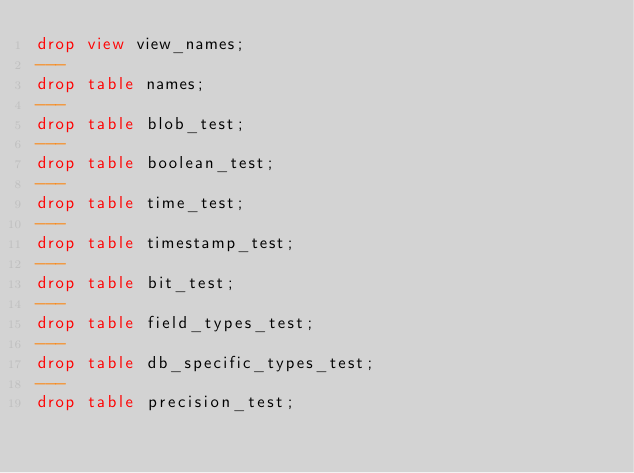<code> <loc_0><loc_0><loc_500><loc_500><_SQL_>drop view view_names;
---
drop table names;
---
drop table blob_test;
---
drop table boolean_test;
---
drop table time_test;
---
drop table timestamp_test;
---
drop table bit_test;
---
drop table field_types_test;
---
drop table db_specific_types_test;
---
drop table precision_test;
</code> 